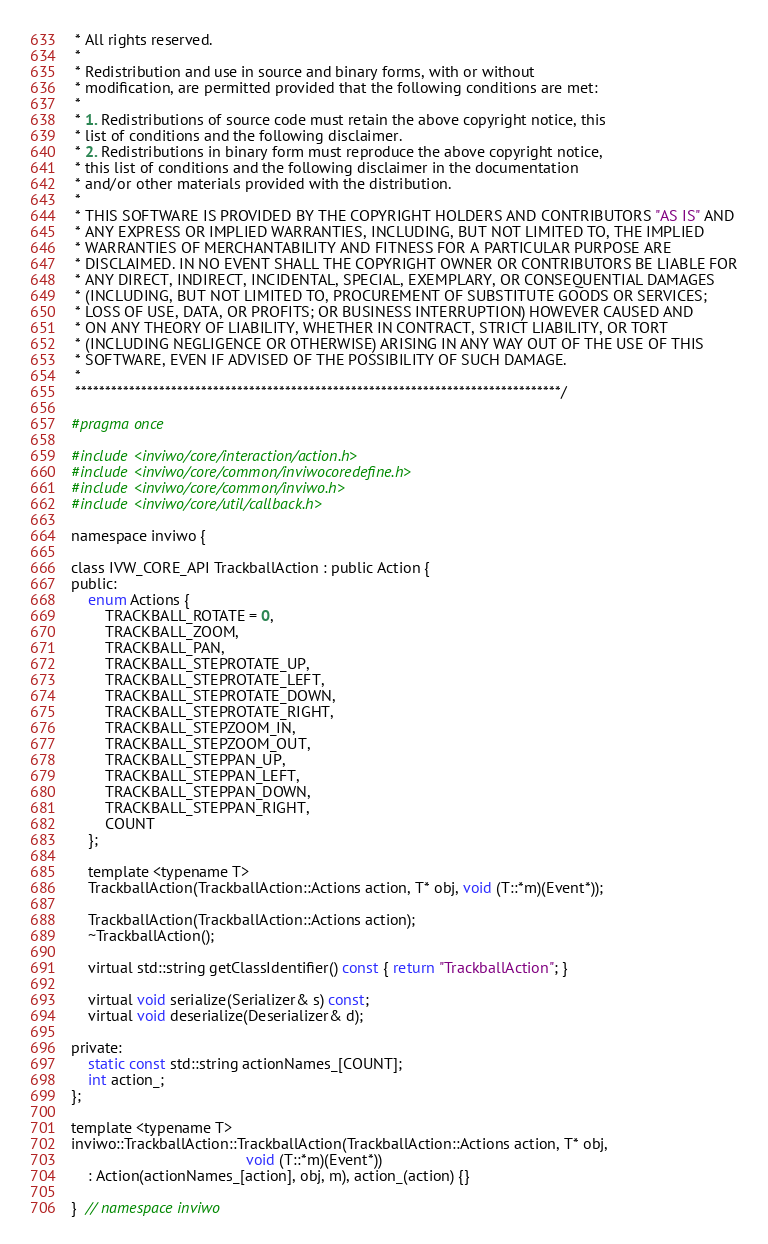Convert code to text. <code><loc_0><loc_0><loc_500><loc_500><_C_> * All rights reserved.
 *
 * Redistribution and use in source and binary forms, with or without
 * modification, are permitted provided that the following conditions are met:
 *
 * 1. Redistributions of source code must retain the above copyright notice, this
 * list of conditions and the following disclaimer.
 * 2. Redistributions in binary form must reproduce the above copyright notice,
 * this list of conditions and the following disclaimer in the documentation
 * and/or other materials provided with the distribution.
 *
 * THIS SOFTWARE IS PROVIDED BY THE COPYRIGHT HOLDERS AND CONTRIBUTORS "AS IS" AND
 * ANY EXPRESS OR IMPLIED WARRANTIES, INCLUDING, BUT NOT LIMITED TO, THE IMPLIED
 * WARRANTIES OF MERCHANTABILITY AND FITNESS FOR A PARTICULAR PURPOSE ARE
 * DISCLAIMED. IN NO EVENT SHALL THE COPYRIGHT OWNER OR CONTRIBUTORS BE LIABLE FOR
 * ANY DIRECT, INDIRECT, INCIDENTAL, SPECIAL, EXEMPLARY, OR CONSEQUENTIAL DAMAGES
 * (INCLUDING, BUT NOT LIMITED TO, PROCUREMENT OF SUBSTITUTE GOODS OR SERVICES;
 * LOSS OF USE, DATA, OR PROFITS; OR BUSINESS INTERRUPTION) HOWEVER CAUSED AND
 * ON ANY THEORY OF LIABILITY, WHETHER IN CONTRACT, STRICT LIABILITY, OR TORT
 * (INCLUDING NEGLIGENCE OR OTHERWISE) ARISING IN ANY WAY OUT OF THE USE OF THIS
 * SOFTWARE, EVEN IF ADVISED OF THE POSSIBILITY OF SUCH DAMAGE.
 *
 *********************************************************************************/

#pragma once

#include <inviwo/core/interaction/action.h>
#include <inviwo/core/common/inviwocoredefine.h>
#include <inviwo/core/common/inviwo.h>
#include <inviwo/core/util/callback.h>

namespace inviwo {

class IVW_CORE_API TrackballAction : public Action {
public:
    enum Actions {
        TRACKBALL_ROTATE = 0,
        TRACKBALL_ZOOM,
        TRACKBALL_PAN,
        TRACKBALL_STEPROTATE_UP,
        TRACKBALL_STEPROTATE_LEFT,
        TRACKBALL_STEPROTATE_DOWN,
        TRACKBALL_STEPROTATE_RIGHT,
        TRACKBALL_STEPZOOM_IN,
        TRACKBALL_STEPZOOM_OUT,
        TRACKBALL_STEPPAN_UP,
        TRACKBALL_STEPPAN_LEFT,
        TRACKBALL_STEPPAN_DOWN,
        TRACKBALL_STEPPAN_RIGHT,
        COUNT
    };

    template <typename T>
    TrackballAction(TrackballAction::Actions action, T* obj, void (T::*m)(Event*));

    TrackballAction(TrackballAction::Actions action);
    ~TrackballAction();

    virtual std::string getClassIdentifier() const { return "TrackballAction"; }

    virtual void serialize(Serializer& s) const;
    virtual void deserialize(Deserializer& d);

private:
    static const std::string actionNames_[COUNT];
    int action_;
};

template <typename T>
inviwo::TrackballAction::TrackballAction(TrackballAction::Actions action, T* obj,
                                         void (T::*m)(Event*))
    : Action(actionNames_[action], obj, m), action_(action) {}

}  // namespace inviwo
</code> 